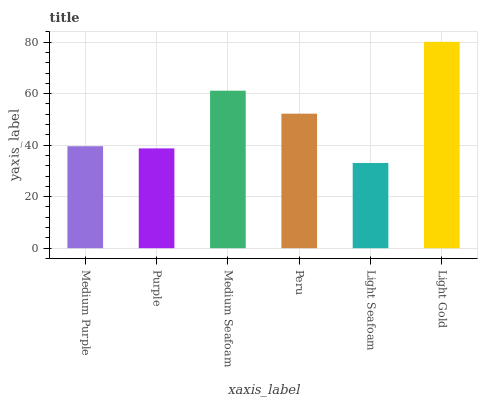Is Light Seafoam the minimum?
Answer yes or no. Yes. Is Light Gold the maximum?
Answer yes or no. Yes. Is Purple the minimum?
Answer yes or no. No. Is Purple the maximum?
Answer yes or no. No. Is Medium Purple greater than Purple?
Answer yes or no. Yes. Is Purple less than Medium Purple?
Answer yes or no. Yes. Is Purple greater than Medium Purple?
Answer yes or no. No. Is Medium Purple less than Purple?
Answer yes or no. No. Is Peru the high median?
Answer yes or no. Yes. Is Medium Purple the low median?
Answer yes or no. Yes. Is Medium Seafoam the high median?
Answer yes or no. No. Is Light Seafoam the low median?
Answer yes or no. No. 